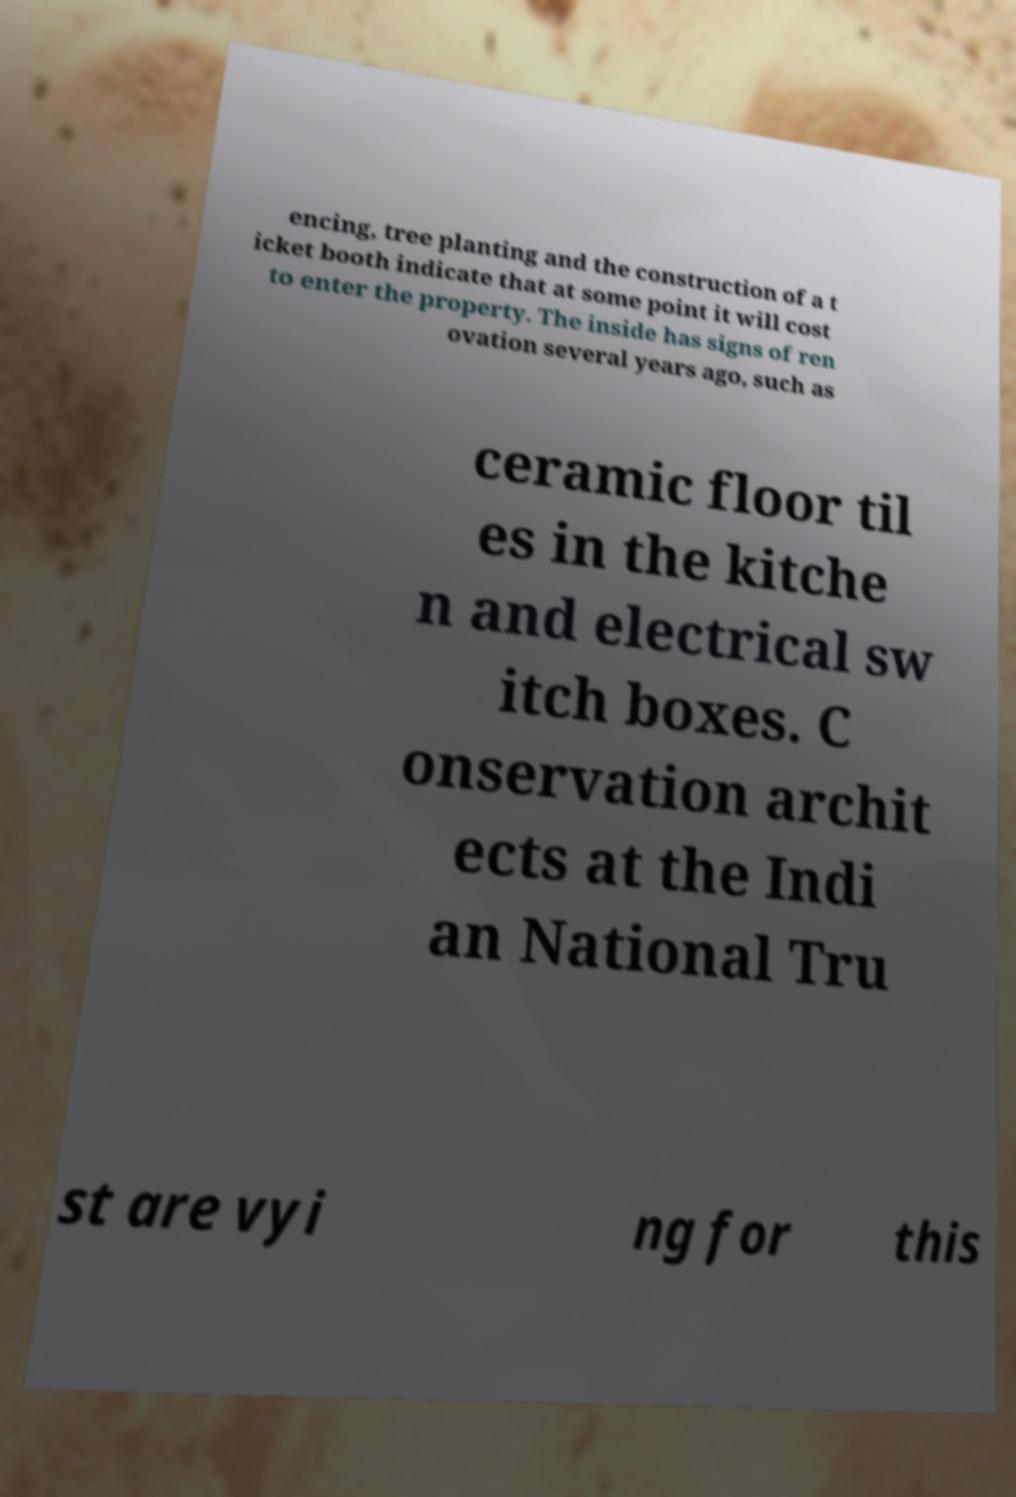I need the written content from this picture converted into text. Can you do that? encing, tree planting and the construction of a t icket booth indicate that at some point it will cost to enter the property. The inside has signs of ren ovation several years ago, such as ceramic floor til es in the kitche n and electrical sw itch boxes. C onservation archit ects at the Indi an National Tru st are vyi ng for this 